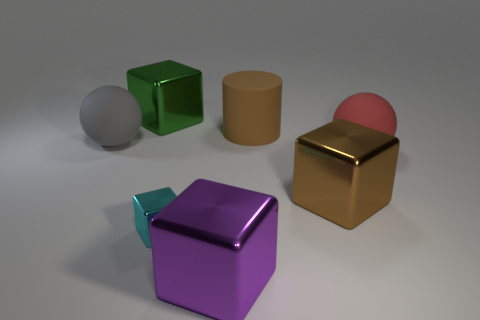Does the large cylinder have the same color as the tiny object?
Keep it short and to the point. No. How many large cubes are both in front of the big green metal cube and on the left side of the brown matte cylinder?
Provide a succinct answer. 1. There is a big brown matte thing on the right side of the big sphere that is to the left of the big red matte ball; how many matte balls are right of it?
Keep it short and to the point. 1. What size is the cube that is the same color as the large cylinder?
Your answer should be very brief. Large. The large gray matte object has what shape?
Provide a short and direct response. Sphere. What number of large green things are made of the same material as the cyan block?
Offer a very short reply. 1. The big ball that is the same material as the gray thing is what color?
Offer a terse response. Red. Do the cylinder and the shiny object behind the large red matte sphere have the same size?
Provide a short and direct response. Yes. What is the material of the ball that is to the right of the big rubber sphere that is to the left of the metal object on the right side of the big purple thing?
Give a very brief answer. Rubber. What number of objects are large green cubes or gray balls?
Your answer should be very brief. 2. 